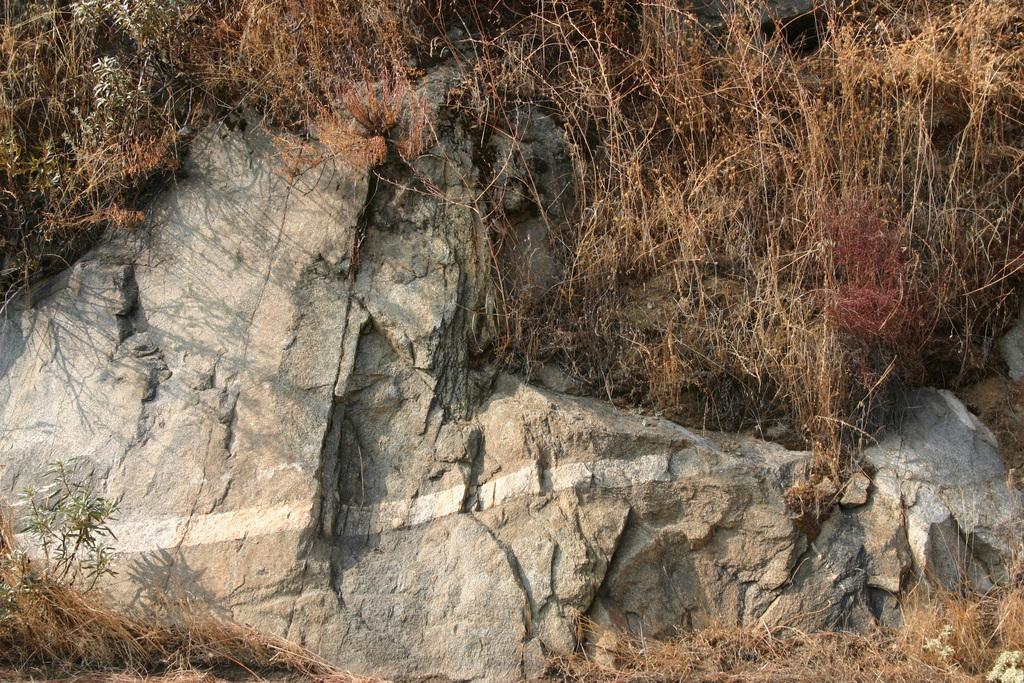How would you summarize this image in a sentence or two? In this image I can see a stone and grass. 